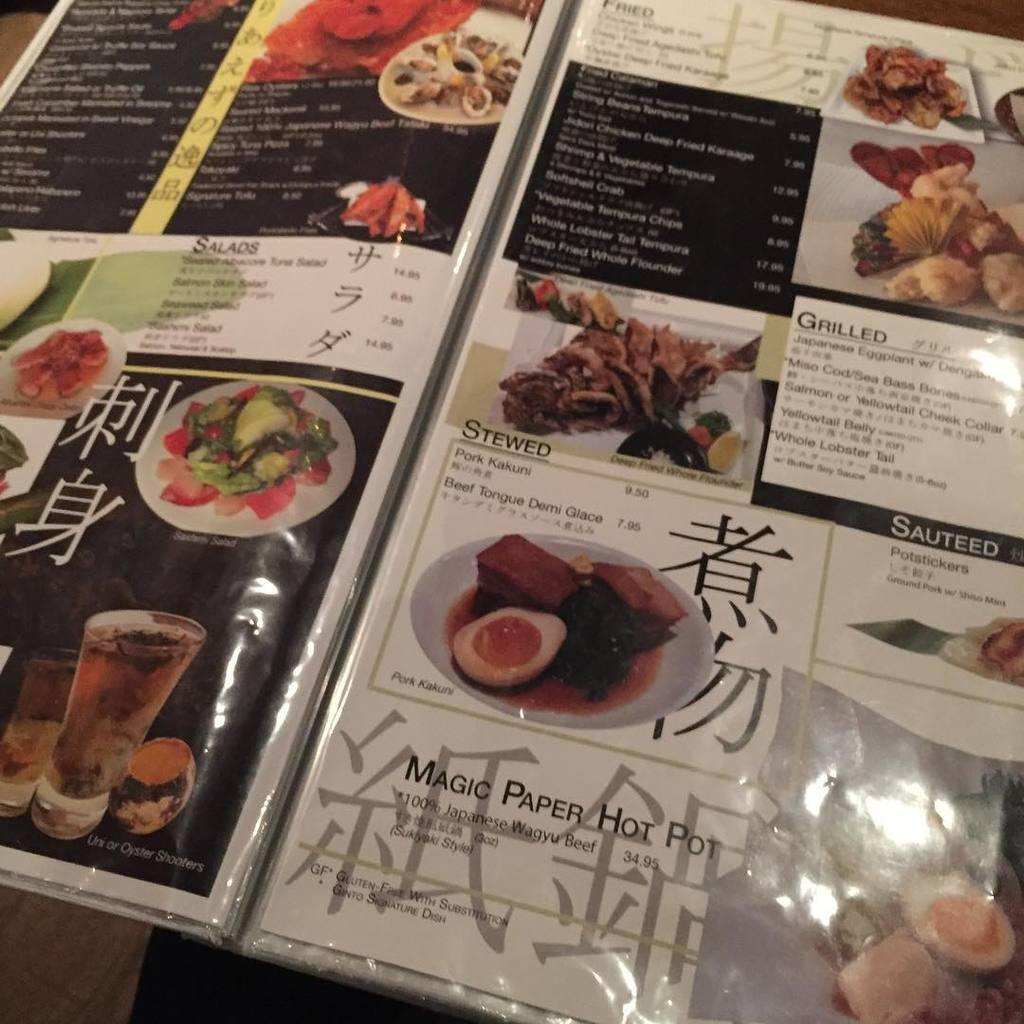What is the main object in the image? There is a menu card in the image. What information is present on the menu card? The menu card contains text and pictures. What types of pictures can be seen on the menu card? The menu card has pictures of plates, food, and a glass. Can you tell me how many pieces of cake are on the menu card? There is no cake present on the menu card; it only contains pictures of plates, food, and a glass. Is there a girl holding the menu card in the image? There is no girl present in the image; it only features the menu card. 